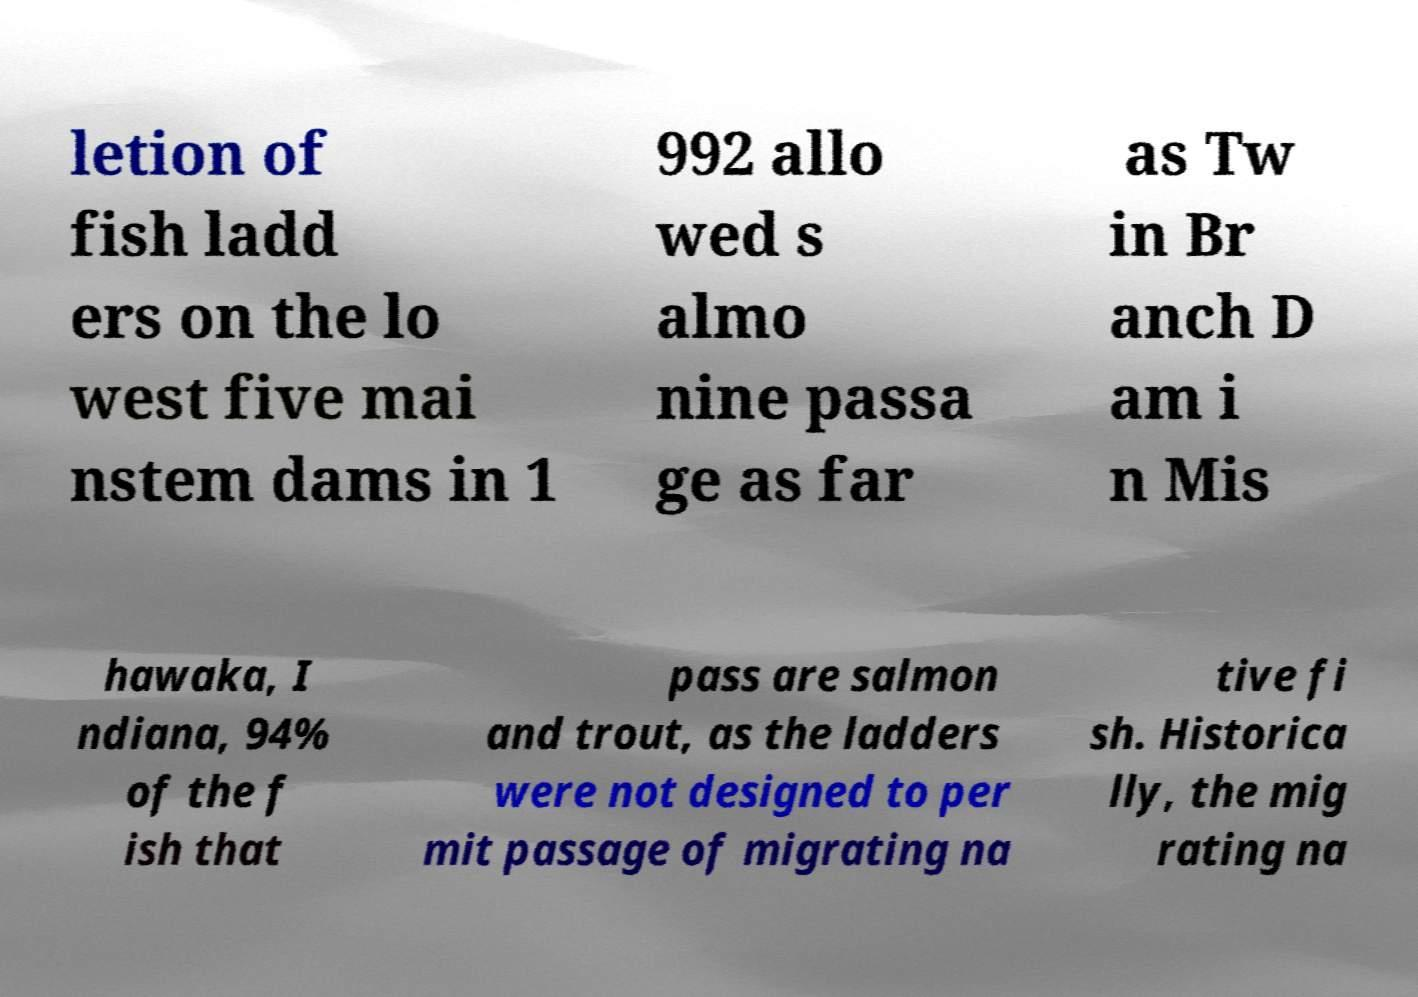Can you read and provide the text displayed in the image?This photo seems to have some interesting text. Can you extract and type it out for me? letion of fish ladd ers on the lo west five mai nstem dams in 1 992 allo wed s almo nine passa ge as far as Tw in Br anch D am i n Mis hawaka, I ndiana, 94% of the f ish that pass are salmon and trout, as the ladders were not designed to per mit passage of migrating na tive fi sh. Historica lly, the mig rating na 